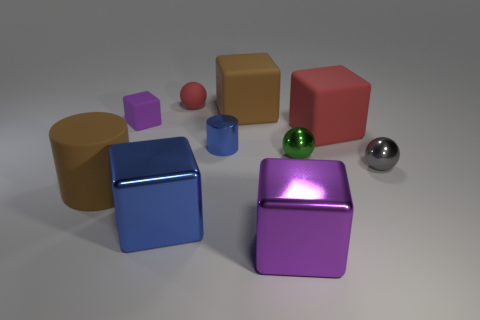What number of objects are both right of the tiny purple matte block and in front of the large brown rubber block?
Offer a very short reply. 6. How many objects are metal objects or big brown rubber objects on the right side of the brown cylinder?
Ensure brevity in your answer.  6. There is a big matte object that is the same color as the rubber cylinder; what shape is it?
Your answer should be very brief. Cube. There is a big rubber block behind the red matte cube; what is its color?
Offer a very short reply. Brown. How many objects are either brown cylinders to the left of the green shiny object or yellow cylinders?
Make the answer very short. 1. What color is the other matte sphere that is the same size as the green ball?
Ensure brevity in your answer.  Red. Is the number of large red rubber cubes that are in front of the brown rubber cylinder greater than the number of gray balls?
Make the answer very short. No. There is a thing that is to the right of the big blue cube and in front of the tiny gray sphere; what is its material?
Keep it short and to the point. Metal. Is the color of the large object behind the big red block the same as the big rubber object that is left of the small blue cylinder?
Your response must be concise. Yes. What number of other objects are there of the same size as the red sphere?
Give a very brief answer. 4. 